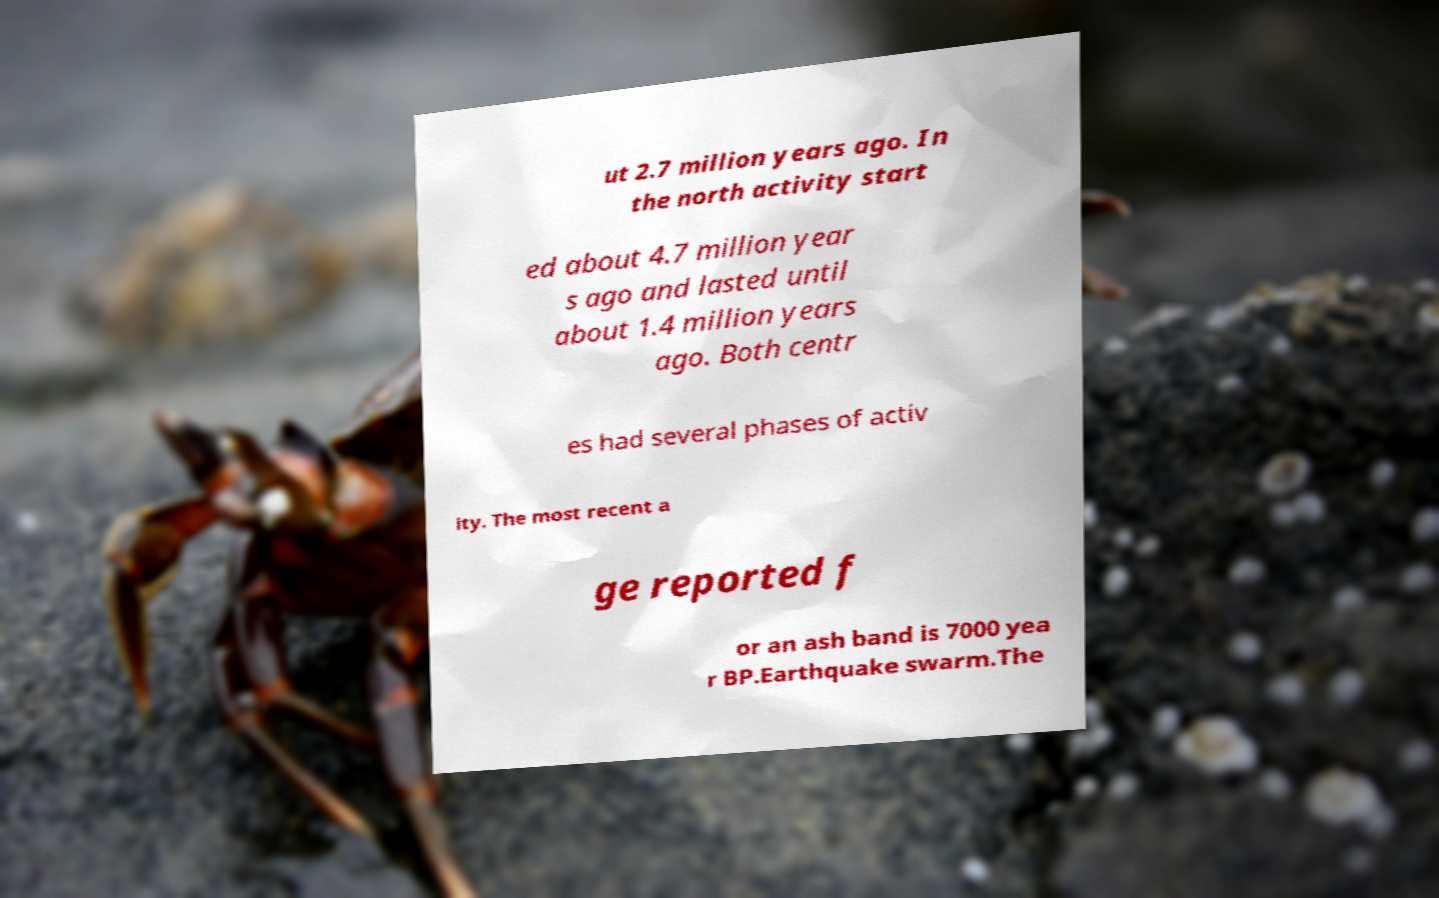I need the written content from this picture converted into text. Can you do that? ut 2.7 million years ago. In the north activity start ed about 4.7 million year s ago and lasted until about 1.4 million years ago. Both centr es had several phases of activ ity. The most recent a ge reported f or an ash band is 7000 yea r BP.Earthquake swarm.The 